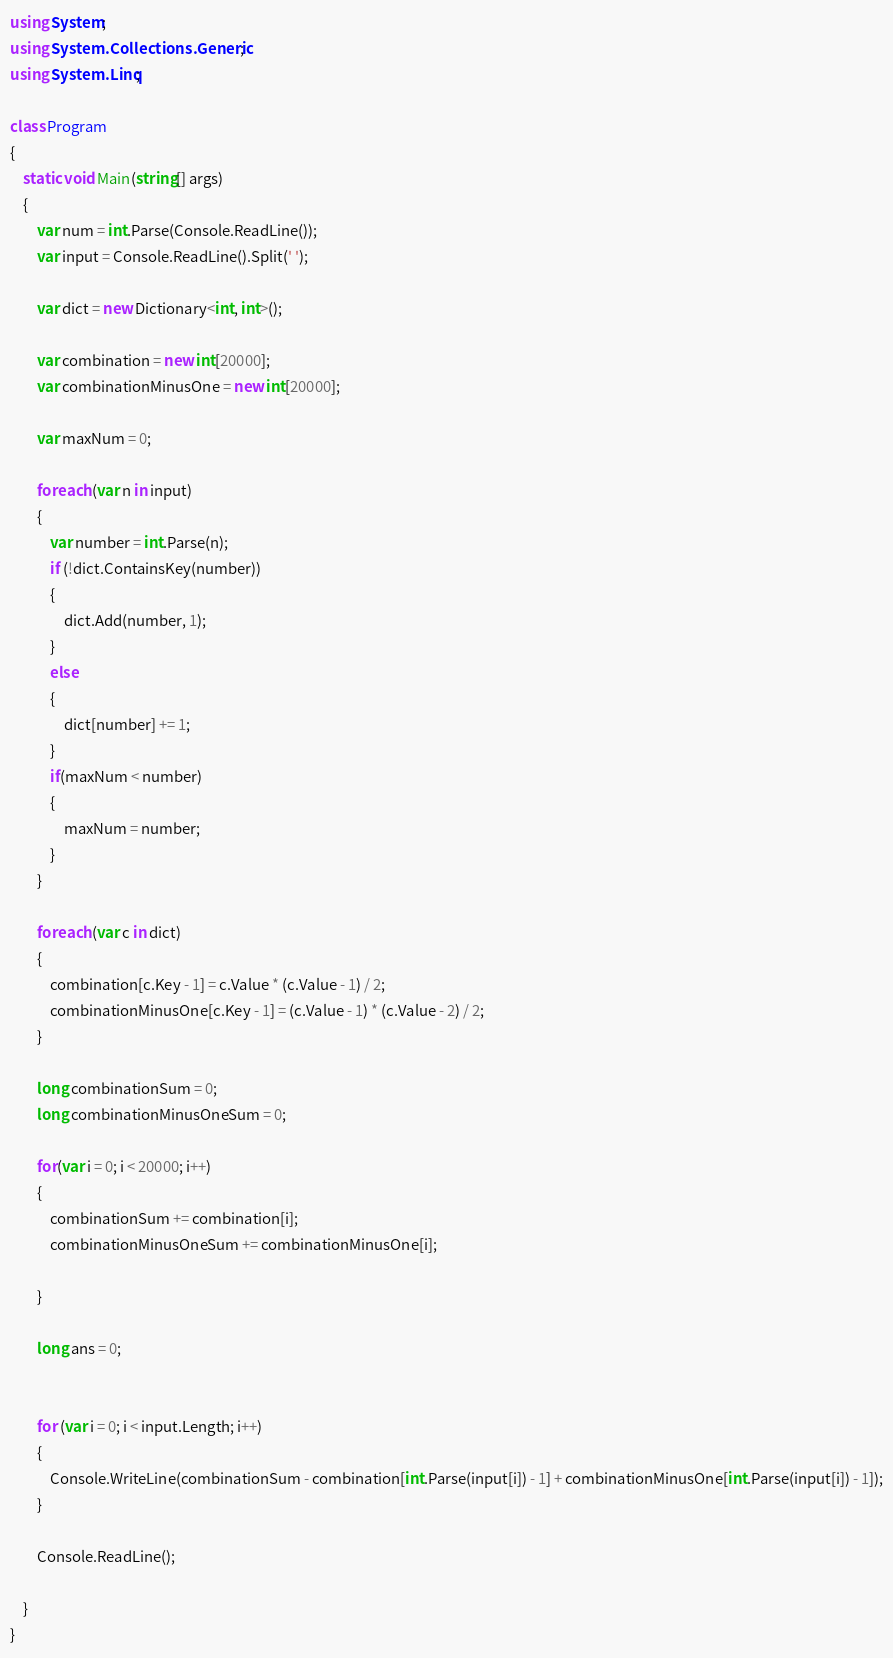Convert code to text. <code><loc_0><loc_0><loc_500><loc_500><_C#_>using System;
using System.Collections.Generic;
using System.Linq;

class Program
{
    static void Main(string[] args)
    {
        var num = int.Parse(Console.ReadLine());
        var input = Console.ReadLine().Split(' ');

        var dict = new Dictionary<int, int>();

        var combination = new int[20000];
        var combinationMinusOne = new int[20000];

        var maxNum = 0;

        foreach (var n in input)
        {
            var number = int.Parse(n);
            if (!dict.ContainsKey(number))
            {
                dict.Add(number, 1);
            }
            else
            {
                dict[number] += 1;
            }
            if(maxNum < number)
            {
                maxNum = number;
            }
        }

        foreach (var c in dict)
        {
            combination[c.Key - 1] = c.Value * (c.Value - 1) / 2;
            combinationMinusOne[c.Key - 1] = (c.Value - 1) * (c.Value - 2) / 2;
        }

        long combinationSum = 0;
        long combinationMinusOneSum = 0;

        for(var i = 0; i < 20000; i++)
        {
            combinationSum += combination[i];
            combinationMinusOneSum += combinationMinusOne[i];

        }

        long ans = 0;


        for (var i = 0; i < input.Length; i++)
        {
            Console.WriteLine(combinationSum - combination[int.Parse(input[i]) - 1] + combinationMinusOne[int.Parse(input[i]) - 1]);
        }

        Console.ReadLine();
        
    }
}
</code> 